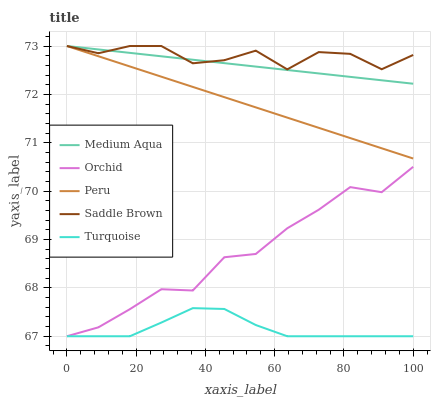Does Turquoise have the minimum area under the curve?
Answer yes or no. Yes. Does Saddle Brown have the maximum area under the curve?
Answer yes or no. Yes. Does Medium Aqua have the minimum area under the curve?
Answer yes or no. No. Does Medium Aqua have the maximum area under the curve?
Answer yes or no. No. Is Peru the smoothest?
Answer yes or no. Yes. Is Saddle Brown the roughest?
Answer yes or no. Yes. Is Medium Aqua the smoothest?
Answer yes or no. No. Is Medium Aqua the roughest?
Answer yes or no. No. Does Medium Aqua have the lowest value?
Answer yes or no. No. Does Orchid have the highest value?
Answer yes or no. No. Is Orchid less than Medium Aqua?
Answer yes or no. Yes. Is Saddle Brown greater than Orchid?
Answer yes or no. Yes. Does Orchid intersect Medium Aqua?
Answer yes or no. No. 